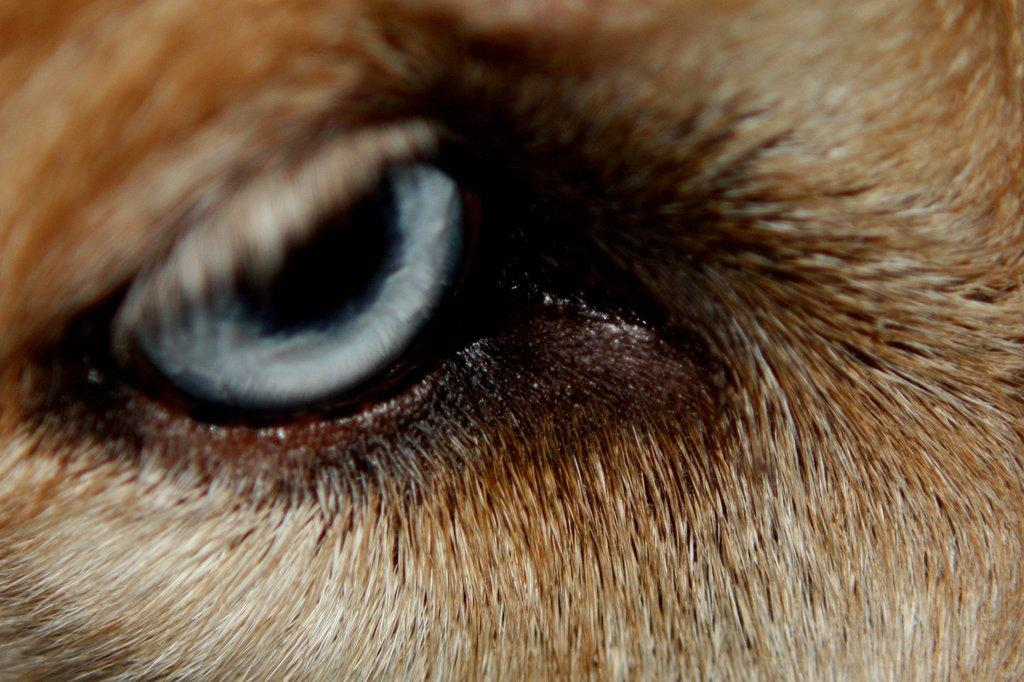What is the main subject of the image? The main subject of the image is an animal eye. Can you see a stream flowing through the animal's horn in the image? There is no horn or stream present in the image; it only features an animal eye. 